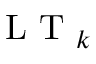Convert formula to latex. <formula><loc_0><loc_0><loc_500><loc_500>L T _ { k }</formula> 